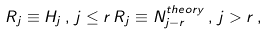Convert formula to latex. <formula><loc_0><loc_0><loc_500><loc_500>R _ { j } \equiv H _ { j } \, , \, j \leq r \, R _ { j } \equiv N _ { j - r } ^ { t h e o r y } \, , \, j > r \, ,</formula> 